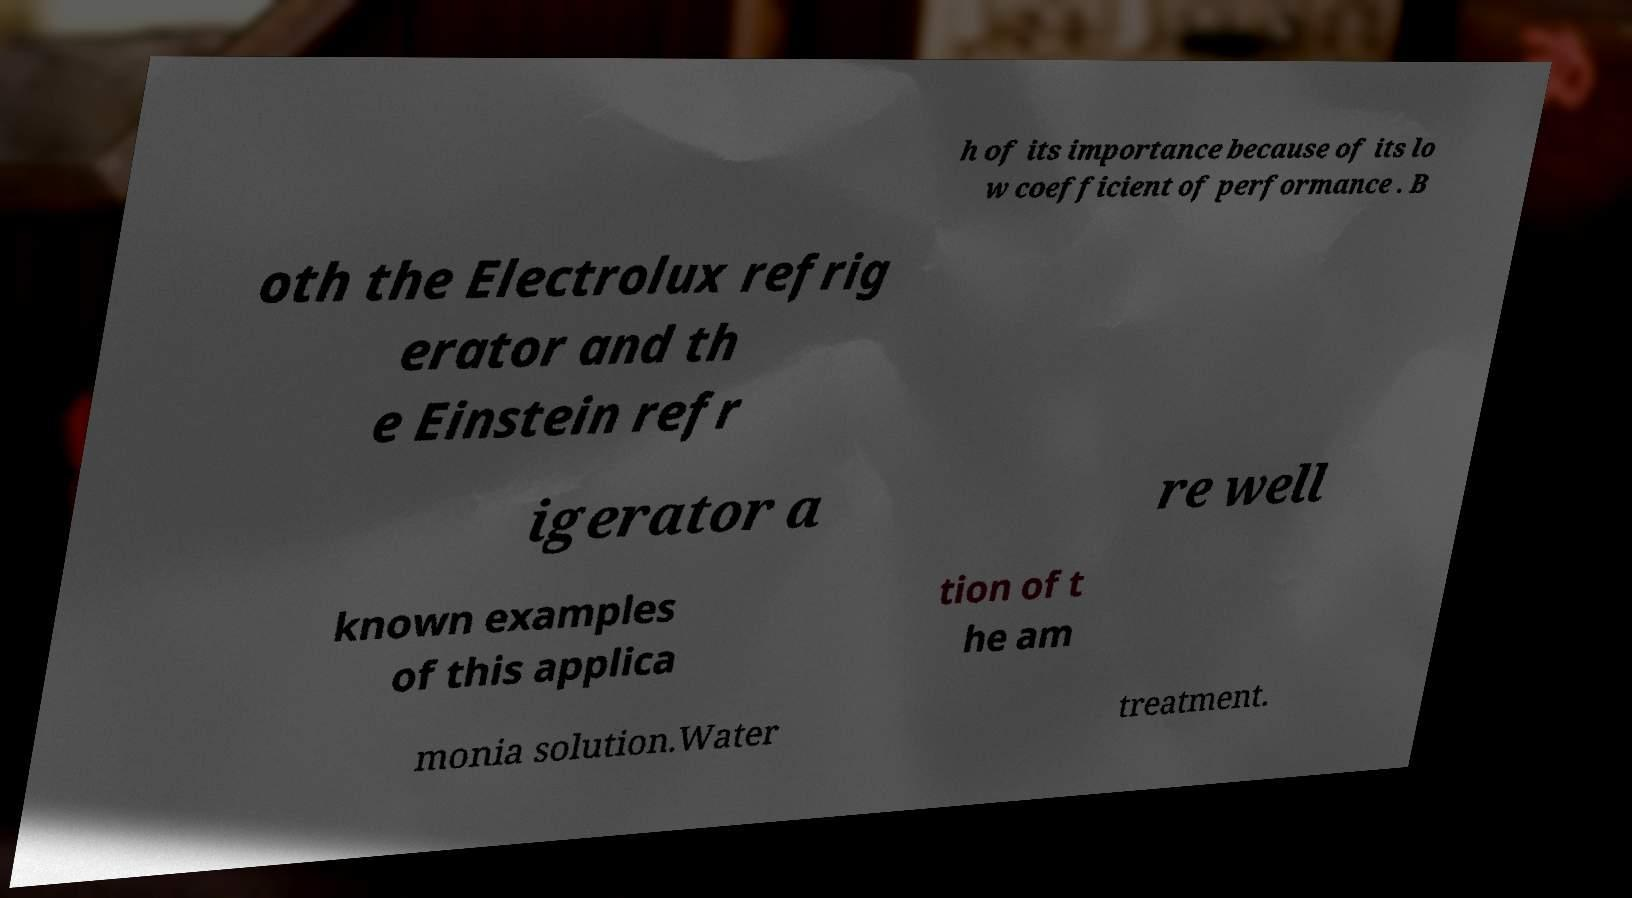I need the written content from this picture converted into text. Can you do that? h of its importance because of its lo w coefficient of performance . B oth the Electrolux refrig erator and th e Einstein refr igerator a re well known examples of this applica tion of t he am monia solution.Water treatment. 